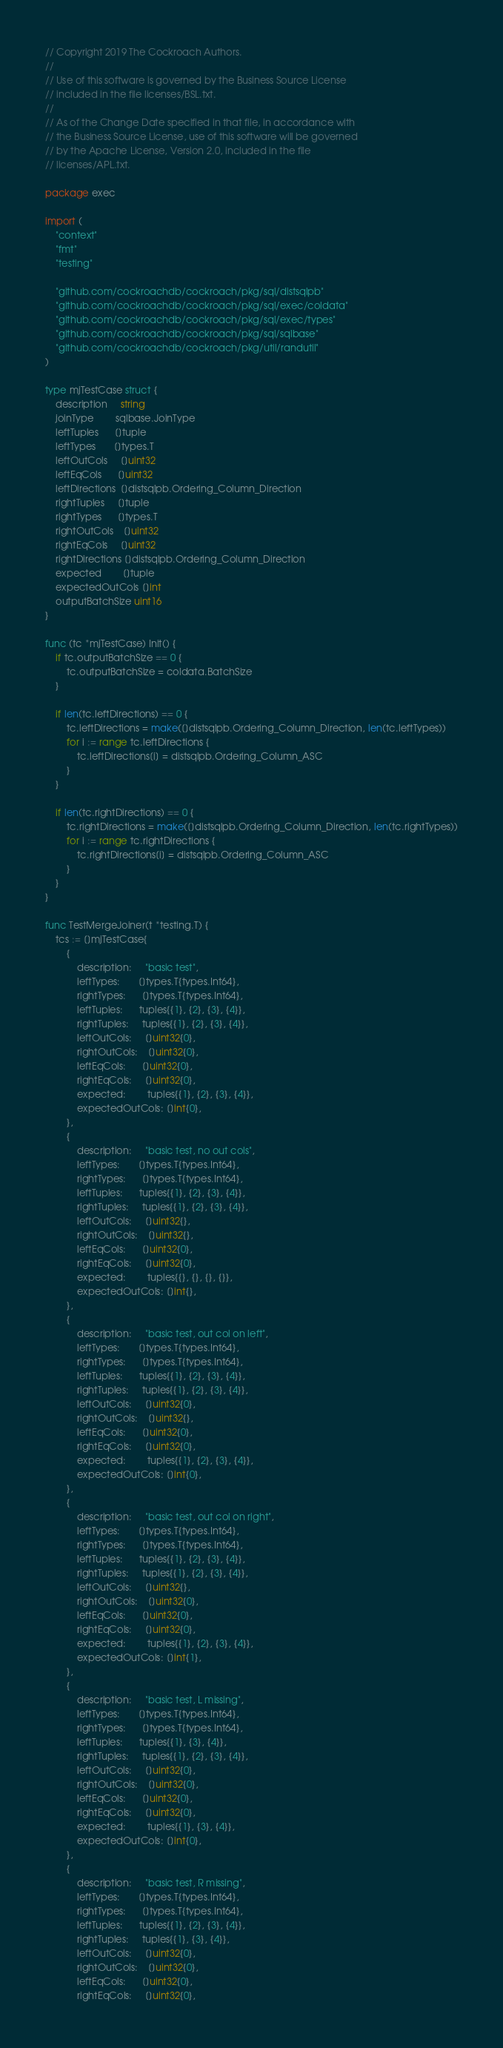Convert code to text. <code><loc_0><loc_0><loc_500><loc_500><_Go_>// Copyright 2019 The Cockroach Authors.
//
// Use of this software is governed by the Business Source License
// included in the file licenses/BSL.txt.
//
// As of the Change Date specified in that file, in accordance with
// the Business Source License, use of this software will be governed
// by the Apache License, Version 2.0, included in the file
// licenses/APL.txt.

package exec

import (
	"context"
	"fmt"
	"testing"

	"github.com/cockroachdb/cockroach/pkg/sql/distsqlpb"
	"github.com/cockroachdb/cockroach/pkg/sql/exec/coldata"
	"github.com/cockroachdb/cockroach/pkg/sql/exec/types"
	"github.com/cockroachdb/cockroach/pkg/sql/sqlbase"
	"github.com/cockroachdb/cockroach/pkg/util/randutil"
)

type mjTestCase struct {
	description     string
	joinType        sqlbase.JoinType
	leftTuples      []tuple
	leftTypes       []types.T
	leftOutCols     []uint32
	leftEqCols      []uint32
	leftDirections  []distsqlpb.Ordering_Column_Direction
	rightTuples     []tuple
	rightTypes      []types.T
	rightOutCols    []uint32
	rightEqCols     []uint32
	rightDirections []distsqlpb.Ordering_Column_Direction
	expected        []tuple
	expectedOutCols []int
	outputBatchSize uint16
}

func (tc *mjTestCase) Init() {
	if tc.outputBatchSize == 0 {
		tc.outputBatchSize = coldata.BatchSize
	}

	if len(tc.leftDirections) == 0 {
		tc.leftDirections = make([]distsqlpb.Ordering_Column_Direction, len(tc.leftTypes))
		for i := range tc.leftDirections {
			tc.leftDirections[i] = distsqlpb.Ordering_Column_ASC
		}
	}

	if len(tc.rightDirections) == 0 {
		tc.rightDirections = make([]distsqlpb.Ordering_Column_Direction, len(tc.rightTypes))
		for i := range tc.rightDirections {
			tc.rightDirections[i] = distsqlpb.Ordering_Column_ASC
		}
	}
}

func TestMergeJoiner(t *testing.T) {
	tcs := []mjTestCase{
		{
			description:     "basic test",
			leftTypes:       []types.T{types.Int64},
			rightTypes:      []types.T{types.Int64},
			leftTuples:      tuples{{1}, {2}, {3}, {4}},
			rightTuples:     tuples{{1}, {2}, {3}, {4}},
			leftOutCols:     []uint32{0},
			rightOutCols:    []uint32{0},
			leftEqCols:      []uint32{0},
			rightEqCols:     []uint32{0},
			expected:        tuples{{1}, {2}, {3}, {4}},
			expectedOutCols: []int{0},
		},
		{
			description:     "basic test, no out cols",
			leftTypes:       []types.T{types.Int64},
			rightTypes:      []types.T{types.Int64},
			leftTuples:      tuples{{1}, {2}, {3}, {4}},
			rightTuples:     tuples{{1}, {2}, {3}, {4}},
			leftOutCols:     []uint32{},
			rightOutCols:    []uint32{},
			leftEqCols:      []uint32{0},
			rightEqCols:     []uint32{0},
			expected:        tuples{{}, {}, {}, {}},
			expectedOutCols: []int{},
		},
		{
			description:     "basic test, out col on left",
			leftTypes:       []types.T{types.Int64},
			rightTypes:      []types.T{types.Int64},
			leftTuples:      tuples{{1}, {2}, {3}, {4}},
			rightTuples:     tuples{{1}, {2}, {3}, {4}},
			leftOutCols:     []uint32{0},
			rightOutCols:    []uint32{},
			leftEqCols:      []uint32{0},
			rightEqCols:     []uint32{0},
			expected:        tuples{{1}, {2}, {3}, {4}},
			expectedOutCols: []int{0},
		},
		{
			description:     "basic test, out col on right",
			leftTypes:       []types.T{types.Int64},
			rightTypes:      []types.T{types.Int64},
			leftTuples:      tuples{{1}, {2}, {3}, {4}},
			rightTuples:     tuples{{1}, {2}, {3}, {4}},
			leftOutCols:     []uint32{},
			rightOutCols:    []uint32{0},
			leftEqCols:      []uint32{0},
			rightEqCols:     []uint32{0},
			expected:        tuples{{1}, {2}, {3}, {4}},
			expectedOutCols: []int{1},
		},
		{
			description:     "basic test, L missing",
			leftTypes:       []types.T{types.Int64},
			rightTypes:      []types.T{types.Int64},
			leftTuples:      tuples{{1}, {3}, {4}},
			rightTuples:     tuples{{1}, {2}, {3}, {4}},
			leftOutCols:     []uint32{0},
			rightOutCols:    []uint32{0},
			leftEqCols:      []uint32{0},
			rightEqCols:     []uint32{0},
			expected:        tuples{{1}, {3}, {4}},
			expectedOutCols: []int{0},
		},
		{
			description:     "basic test, R missing",
			leftTypes:       []types.T{types.Int64},
			rightTypes:      []types.T{types.Int64},
			leftTuples:      tuples{{1}, {2}, {3}, {4}},
			rightTuples:     tuples{{1}, {3}, {4}},
			leftOutCols:     []uint32{0},
			rightOutCols:    []uint32{0},
			leftEqCols:      []uint32{0},
			rightEqCols:     []uint32{0},</code> 